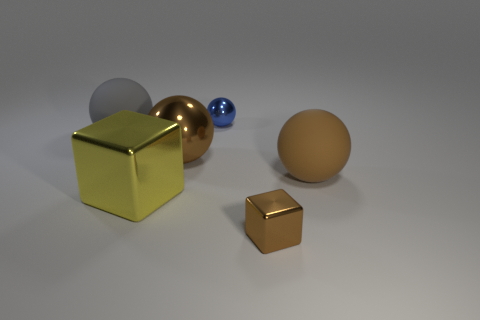Subtract all large gray balls. How many balls are left? 3 Subtract all yellow balls. Subtract all brown cubes. How many balls are left? 4 Add 4 small yellow matte cubes. How many objects exist? 10 Subtract all blocks. How many objects are left? 4 Subtract all large balls. Subtract all matte spheres. How many objects are left? 1 Add 3 tiny blue metal things. How many tiny blue metal things are left? 4 Add 2 blue metallic objects. How many blue metallic objects exist? 3 Subtract 0 cyan spheres. How many objects are left? 6 